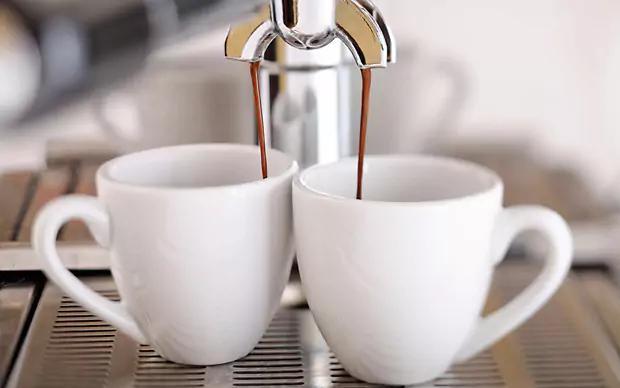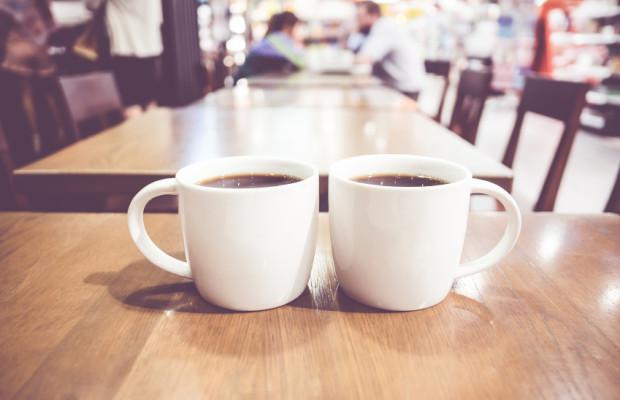The first image is the image on the left, the second image is the image on the right. For the images shown, is this caption "Each image shows two hot drinks served in matching cups with handles, seen at angle where the contents are visible." true? Answer yes or no. No. The first image is the image on the left, the second image is the image on the right. Analyze the images presented: Is the assertion "An image shows exactly two already filled round white cups sitting side-by-side horizontally without saucers, with handles turned outward." valid? Answer yes or no. Yes. 